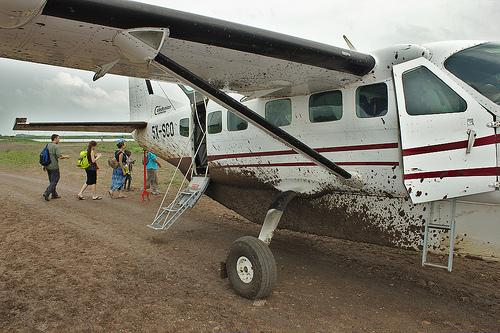What is the location of the ladder in relation to the aircraft? The ladder is protruding from the side of the aircraft. Describe the color and pattern on the airplane's exterior. The airplane is white with red stripes. What is the condition of the side of the airplane, and what might have caused it? Dirt splattered onto the side of the aircraft, possibly due to the muddy ground. Describe an object in the image that is related to the airplane's takeoff and landing. There is a wheel on the back of the plane. Identify the type of footwear worn by one of the individuals in the image and describe it briefly. A woman is wearing flip flops on her feet. Name three objects that can be found in the image and describe their appearance. A large airplane tire, a woman wearing a yellow backpack, and an open cockpit door. What does one woman in the image have in common with one of the men? Both the woman and the man are wearing blue backpacks. What is a notable feature of the ground in the image? The ground is brown and muddy. How many windows can be found between the doors of the plane? There are five windows. What activity is a group of people engaged in behind the airplane? The group of people is walking behind the plane. 